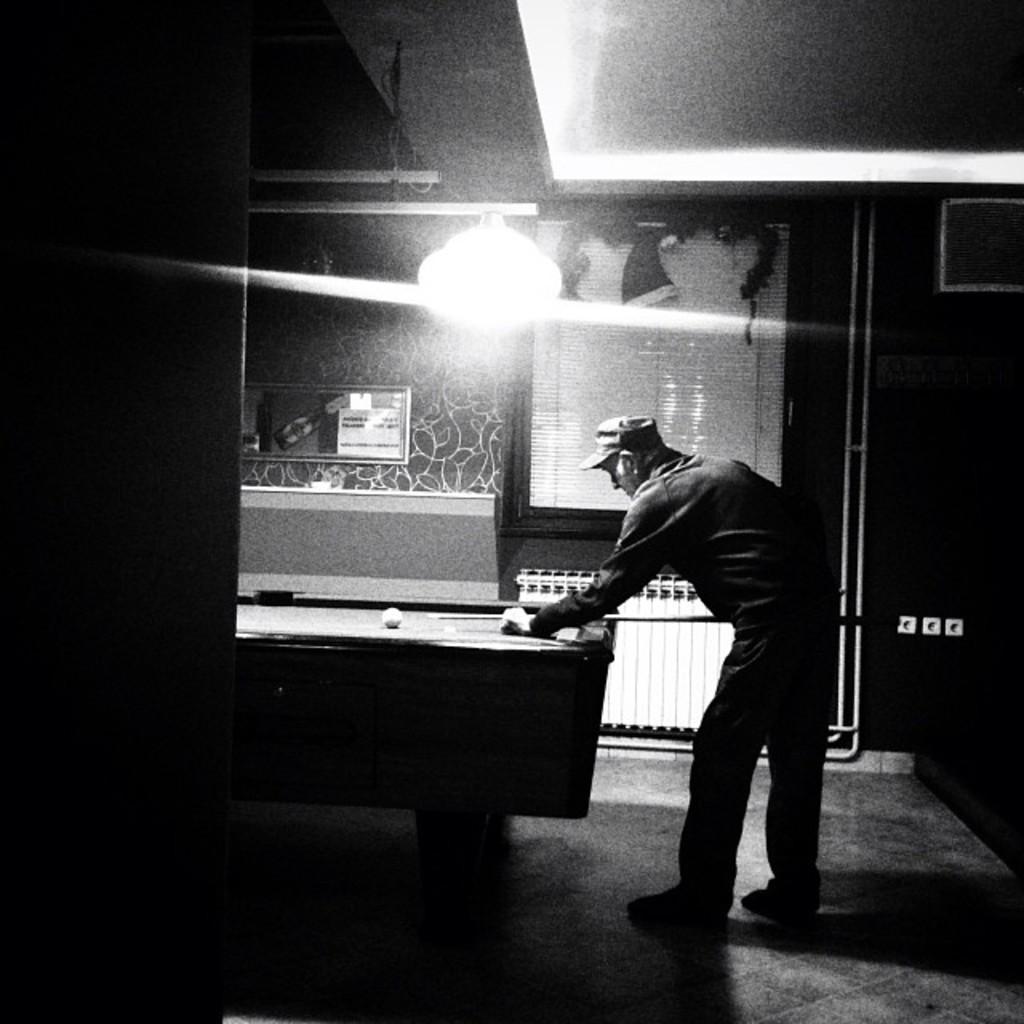Can you describe this image briefly? This picture is of inside the room. On the right there is a man standing and playing billiards game. In the background we can see the lamp, window blind, table, wall and a picture frame hanging on the wall. 